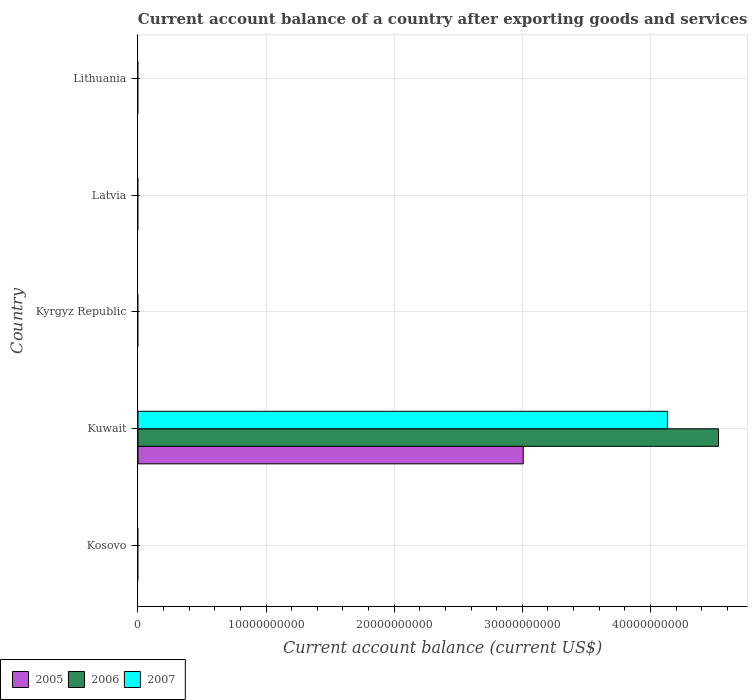How many different coloured bars are there?
Keep it short and to the point. 3. What is the label of the 5th group of bars from the top?
Your answer should be compact. Kosovo. What is the account balance in 2007 in Lithuania?
Provide a short and direct response. 0. Across all countries, what is the maximum account balance in 2005?
Provide a succinct answer. 3.01e+1. Across all countries, what is the minimum account balance in 2006?
Give a very brief answer. 0. In which country was the account balance in 2007 maximum?
Your answer should be very brief. Kuwait. What is the total account balance in 2005 in the graph?
Provide a short and direct response. 3.01e+1. What is the difference between the account balance in 2005 in Lithuania and the account balance in 2007 in Latvia?
Your response must be concise. 0. What is the average account balance in 2005 per country?
Provide a short and direct response. 6.01e+09. What is the difference between the account balance in 2006 and account balance in 2007 in Kuwait?
Offer a very short reply. 3.98e+09. What is the difference between the highest and the lowest account balance in 2005?
Your response must be concise. 3.01e+1. In how many countries, is the account balance in 2007 greater than the average account balance in 2007 taken over all countries?
Keep it short and to the point. 1. Is it the case that in every country, the sum of the account balance in 2006 and account balance in 2007 is greater than the account balance in 2005?
Offer a terse response. No. Are all the bars in the graph horizontal?
Make the answer very short. Yes. How many countries are there in the graph?
Keep it short and to the point. 5. What is the difference between two consecutive major ticks on the X-axis?
Offer a terse response. 1.00e+1. Are the values on the major ticks of X-axis written in scientific E-notation?
Make the answer very short. No. Does the graph contain grids?
Keep it short and to the point. Yes. Where does the legend appear in the graph?
Provide a succinct answer. Bottom left. How are the legend labels stacked?
Your answer should be compact. Horizontal. What is the title of the graph?
Your answer should be very brief. Current account balance of a country after exporting goods and services. Does "2009" appear as one of the legend labels in the graph?
Make the answer very short. No. What is the label or title of the X-axis?
Keep it short and to the point. Current account balance (current US$). What is the Current account balance (current US$) in 2007 in Kosovo?
Provide a short and direct response. 0. What is the Current account balance (current US$) of 2005 in Kuwait?
Keep it short and to the point. 3.01e+1. What is the Current account balance (current US$) of 2006 in Kuwait?
Give a very brief answer. 4.53e+1. What is the Current account balance (current US$) in 2007 in Kuwait?
Your response must be concise. 4.13e+1. What is the Current account balance (current US$) of 2006 in Kyrgyz Republic?
Offer a very short reply. 0. What is the Current account balance (current US$) in 2007 in Kyrgyz Republic?
Your answer should be very brief. 0. What is the Current account balance (current US$) in 2005 in Latvia?
Your response must be concise. 0. What is the Current account balance (current US$) of 2006 in Latvia?
Your response must be concise. 0. What is the Current account balance (current US$) in 2007 in Latvia?
Your answer should be very brief. 0. What is the Current account balance (current US$) of 2005 in Lithuania?
Provide a succinct answer. 0. What is the Current account balance (current US$) in 2006 in Lithuania?
Make the answer very short. 0. What is the Current account balance (current US$) in 2007 in Lithuania?
Offer a very short reply. 0. Across all countries, what is the maximum Current account balance (current US$) in 2005?
Make the answer very short. 3.01e+1. Across all countries, what is the maximum Current account balance (current US$) of 2006?
Your answer should be very brief. 4.53e+1. Across all countries, what is the maximum Current account balance (current US$) in 2007?
Provide a short and direct response. 4.13e+1. Across all countries, what is the minimum Current account balance (current US$) in 2007?
Offer a very short reply. 0. What is the total Current account balance (current US$) in 2005 in the graph?
Your answer should be compact. 3.01e+1. What is the total Current account balance (current US$) of 2006 in the graph?
Offer a terse response. 4.53e+1. What is the total Current account balance (current US$) of 2007 in the graph?
Your response must be concise. 4.13e+1. What is the average Current account balance (current US$) of 2005 per country?
Your answer should be compact. 6.01e+09. What is the average Current account balance (current US$) of 2006 per country?
Offer a terse response. 9.06e+09. What is the average Current account balance (current US$) of 2007 per country?
Your response must be concise. 8.27e+09. What is the difference between the Current account balance (current US$) in 2005 and Current account balance (current US$) in 2006 in Kuwait?
Offer a terse response. -1.52e+1. What is the difference between the Current account balance (current US$) of 2005 and Current account balance (current US$) of 2007 in Kuwait?
Your answer should be compact. -1.13e+1. What is the difference between the Current account balance (current US$) of 2006 and Current account balance (current US$) of 2007 in Kuwait?
Make the answer very short. 3.98e+09. What is the difference between the highest and the lowest Current account balance (current US$) in 2005?
Your answer should be very brief. 3.01e+1. What is the difference between the highest and the lowest Current account balance (current US$) of 2006?
Provide a short and direct response. 4.53e+1. What is the difference between the highest and the lowest Current account balance (current US$) in 2007?
Your response must be concise. 4.13e+1. 